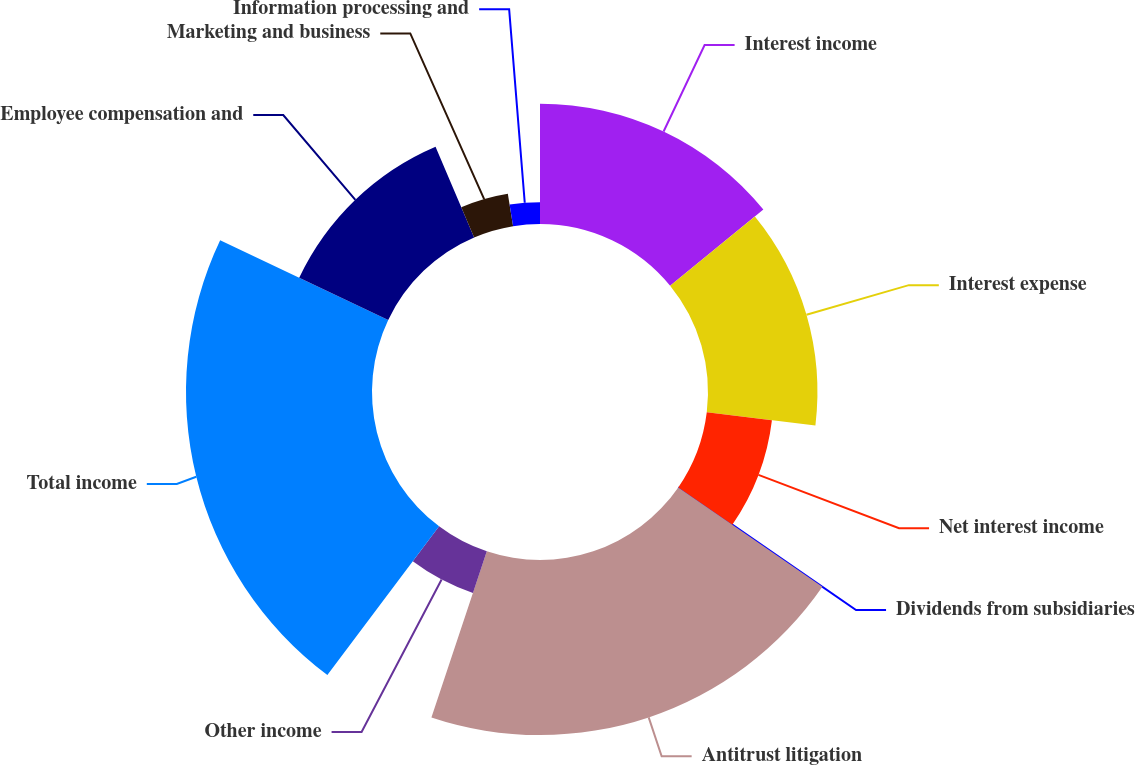Convert chart to OTSL. <chart><loc_0><loc_0><loc_500><loc_500><pie_chart><fcel>Interest income<fcel>Interest expense<fcel>Net interest income<fcel>Dividends from subsidiaries<fcel>Antitrust litigation<fcel>Other income<fcel>Total income<fcel>Employee compensation and<fcel>Marketing and business<fcel>Information processing and<nl><fcel>14.1%<fcel>12.82%<fcel>7.69%<fcel>0.0%<fcel>20.51%<fcel>5.13%<fcel>21.79%<fcel>11.54%<fcel>3.85%<fcel>2.56%<nl></chart> 